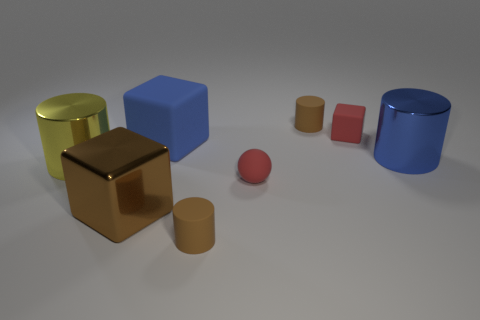How does the lighting in the scene affect the appearance of the objects? The lighting from above creates soft shadows on the ground beneath the objects, highlighting their shapes and giving the scene a three-dimensional feel. It also enhances the reflective properties of the shiny surfaces. 